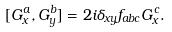<formula> <loc_0><loc_0><loc_500><loc_500>[ G _ { x } ^ { a } , G _ { y } ^ { b } ] = 2 i \delta _ { x y } f _ { a b c } G _ { x } ^ { c } .</formula> 